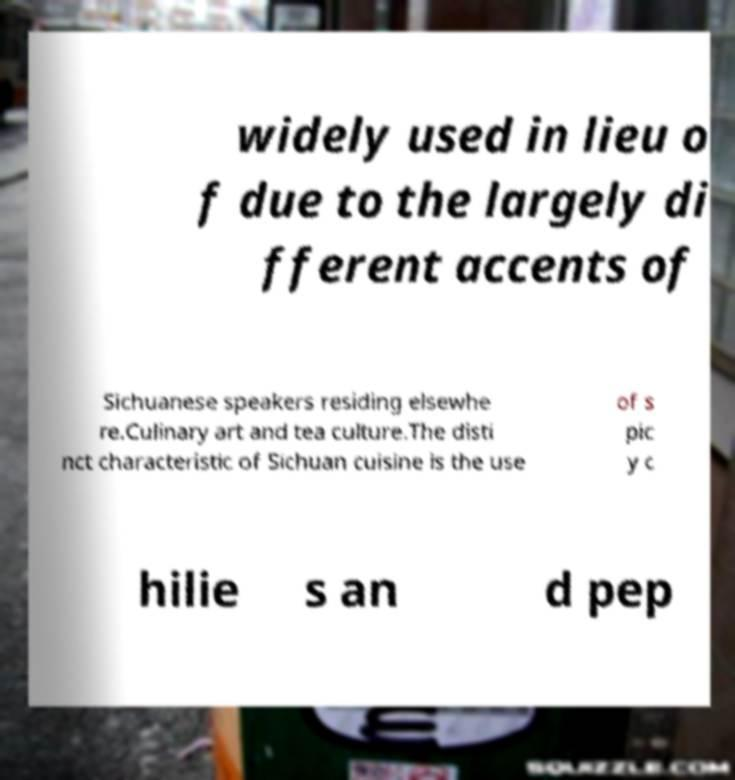Please read and relay the text visible in this image. What does it say? widely used in lieu o f due to the largely di fferent accents of Sichuanese speakers residing elsewhe re.Culinary art and tea culture.The disti nct characteristic of Sichuan cuisine is the use of s pic y c hilie s an d pep 